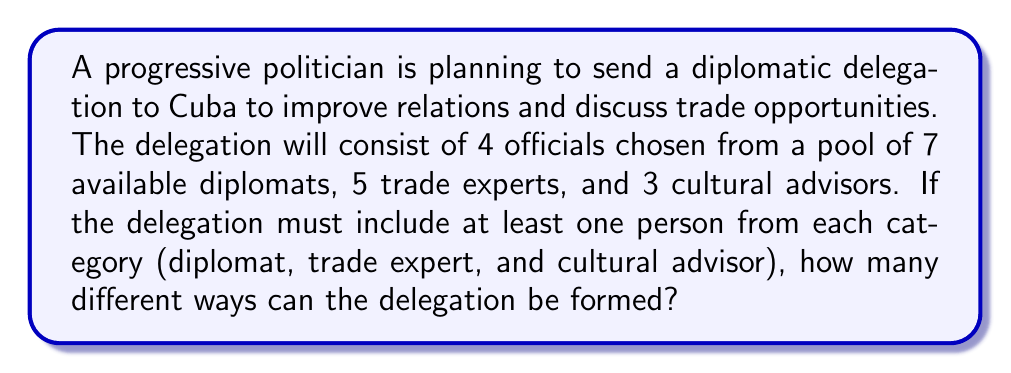Solve this math problem. Let's approach this step-by-step using the concept of combinations:

1) We need to select 4 officials in total, with at least one from each category. This means we have 1 spot left after selecting one from each category.

2) First, let's calculate the number of ways to select the mandatory representatives:
   - 1 diplomat out of 7: $\binom{7}{1} = 7$ ways
   - 1 trade expert out of 5: $\binom{5}{1} = 5$ ways
   - 1 cultural advisor out of 3: $\binom{3}{1} = 3$ ways

3) For the last spot, we can choose from the remaining officials in any category:
   - Remaining officials: 6 diplomats + 4 trade experts + 2 cultural advisors = 12 officials

4) We can select this last official in $\binom{12}{1} = 12$ ways

5) According to the multiplication principle, the total number of ways to form the delegation is:

   $$ 7 \times 5 \times 3 \times 12 = 1260 $$

Therefore, there are 1260 different ways to form the delegation.
Answer: 1260 ways 